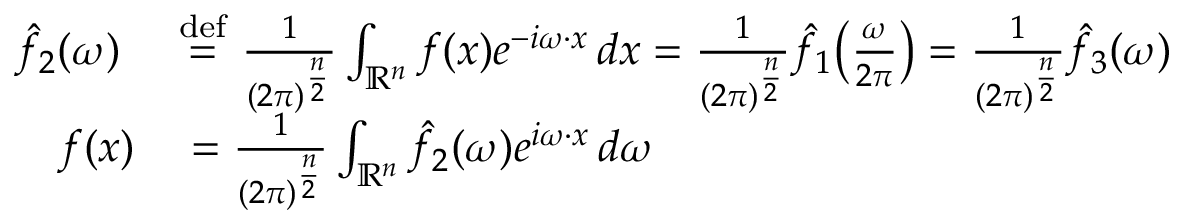Convert formula to latex. <formula><loc_0><loc_0><loc_500><loc_500>\begin{array} { r l } { { \hat { f } } _ { 2 } ( \omega ) \ } & { \stackrel { d e f } { = } } \ { \frac { 1 } { ( 2 \pi ) ^ { \frac { n } { 2 } } } } \int _ { \mathbb { R } ^ { n } } f ( x ) e ^ { - i \omega \cdot x } \, d x = { \frac { 1 } { ( 2 \pi ) ^ { \frac { n } { 2 } } } } { \hat { f } } _ { 1 } \, \left ( { \frac { \omega } { 2 \pi } } \right ) = { \frac { 1 } { ( 2 \pi ) ^ { \frac { n } { 2 } } } } { \hat { f } } _ { 3 } ( \omega ) } \\ { f ( x ) } & = { \frac { 1 } { ( 2 \pi ) ^ { \frac { n } { 2 } } } } \int _ { \mathbb { R } ^ { n } } { \hat { f } } _ { 2 } ( \omega ) e ^ { i \omega \cdot x } \, d \omega } \end{array}</formula> 